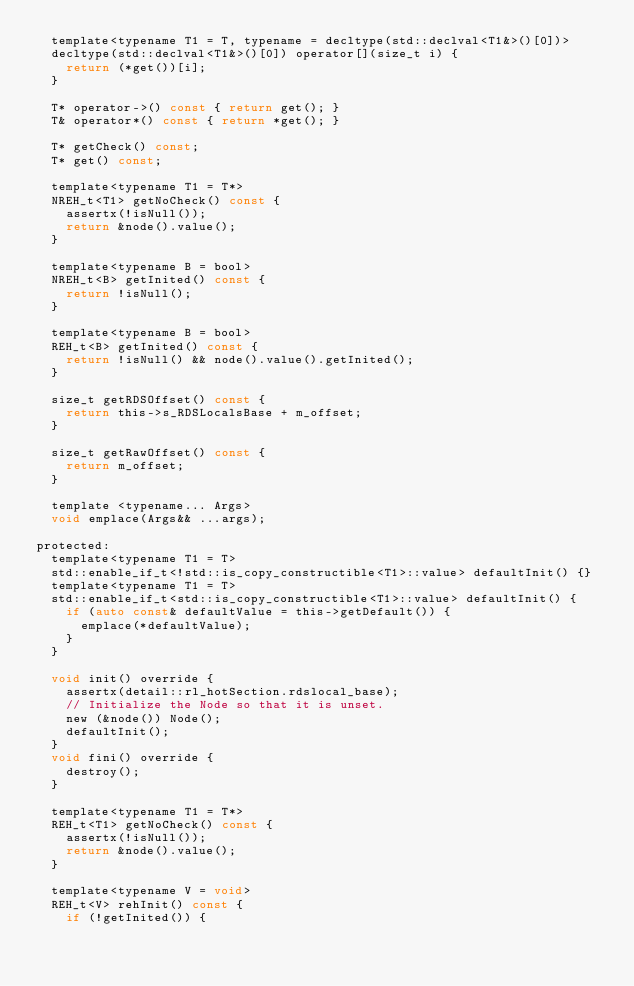Convert code to text. <code><loc_0><loc_0><loc_500><loc_500><_C_>  template<typename T1 = T, typename = decltype(std::declval<T1&>()[0])>
  decltype(std::declval<T1&>()[0]) operator[](size_t i) {
    return (*get())[i];
  }

  T* operator->() const { return get(); }
  T& operator*() const { return *get(); }

  T* getCheck() const;
  T* get() const;

  template<typename T1 = T*>
  NREH_t<T1> getNoCheck() const {
    assertx(!isNull());
    return &node().value();
  }

  template<typename B = bool>
  NREH_t<B> getInited() const {
    return !isNull();
  }

  template<typename B = bool>
  REH_t<B> getInited() const {
    return !isNull() && node().value().getInited();
  }

  size_t getRDSOffset() const {
    return this->s_RDSLocalsBase + m_offset;
  }

  size_t getRawOffset() const {
    return m_offset;
  }

  template <typename... Args>
  void emplace(Args&& ...args);

protected:
  template<typename T1 = T>
  std::enable_if_t<!std::is_copy_constructible<T1>::value> defaultInit() {}
  template<typename T1 = T>
  std::enable_if_t<std::is_copy_constructible<T1>::value> defaultInit() {
    if (auto const& defaultValue = this->getDefault()) {
      emplace(*defaultValue);
    }
  }

  void init() override {
    assertx(detail::rl_hotSection.rdslocal_base);
    // Initialize the Node so that it is unset.
    new (&node()) Node();
    defaultInit();
  }
  void fini() override {
    destroy();
  }

  template<typename T1 = T*>
  REH_t<T1> getNoCheck() const {
    assertx(!isNull());
    return &node().value();
  }

  template<typename V = void>
  REH_t<V> rehInit() const {
    if (!getInited()) {</code> 